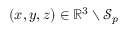<formula> <loc_0><loc_0><loc_500><loc_500>( x , y , z ) \in \mathbb { R } ^ { 3 } \ \mathcal { S } _ { p }</formula> 